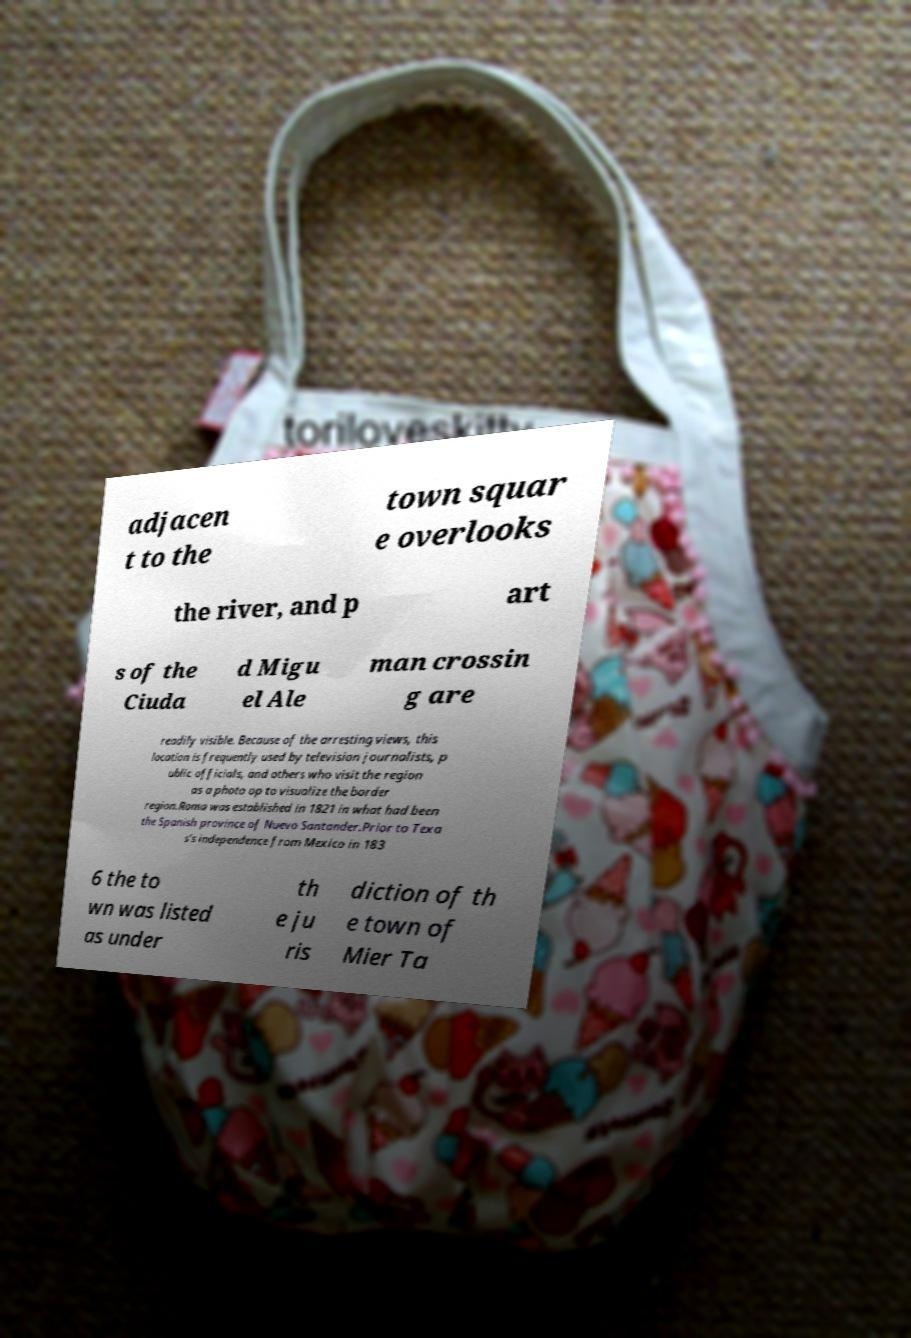Please identify and transcribe the text found in this image. adjacen t to the town squar e overlooks the river, and p art s of the Ciuda d Migu el Ale man crossin g are readily visible. Because of the arresting views, this location is frequently used by television journalists, p ublic officials, and others who visit the region as a photo op to visualize the border region.Roma was established in 1821 in what had been the Spanish province of Nuevo Santander.Prior to Texa s's independence from Mexico in 183 6 the to wn was listed as under th e ju ris diction of th e town of Mier Ta 